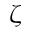<formula> <loc_0><loc_0><loc_500><loc_500>\zeta</formula> 